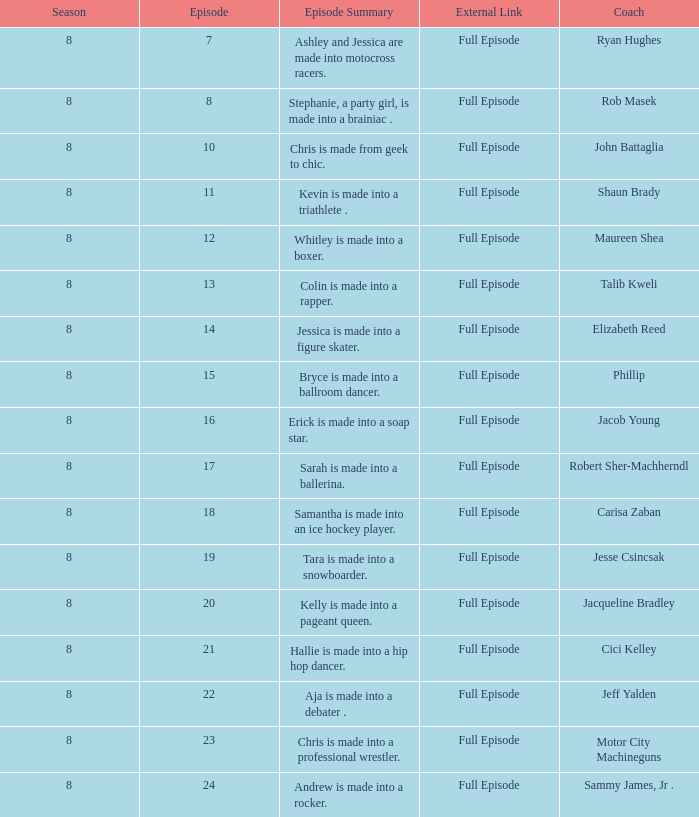Could you parse the entire table? {'header': ['Season', 'Episode', 'Episode Summary', 'External Link', 'Coach'], 'rows': [['8', '7', 'Ashley and Jessica are made into motocross racers.', 'Full Episode', 'Ryan Hughes'], ['8', '8', 'Stephanie, a party girl, is made into a brainiac .', 'Full Episode', 'Rob Masek'], ['8', '10', 'Chris is made from geek to chic.', 'Full Episode', 'John Battaglia'], ['8', '11', 'Kevin is made into a triathlete .', 'Full Episode', 'Shaun Brady'], ['8', '12', 'Whitley is made into a boxer.', 'Full Episode', 'Maureen Shea'], ['8', '13', 'Colin is made into a rapper.', 'Full Episode', 'Talib Kweli'], ['8', '14', 'Jessica is made into a figure skater.', 'Full Episode', 'Elizabeth Reed'], ['8', '15', 'Bryce is made into a ballroom dancer.', 'Full Episode', 'Phillip'], ['8', '16', 'Erick is made into a soap star.', 'Full Episode', 'Jacob Young'], ['8', '17', 'Sarah is made into a ballerina.', 'Full Episode', 'Robert Sher-Machherndl'], ['8', '18', 'Samantha is made into an ice hockey player.', 'Full Episode', 'Carisa Zaban'], ['8', '19', 'Tara is made into a snowboarder.', 'Full Episode', 'Jesse Csincsak'], ['8', '20', 'Kelly is made into a pageant queen.', 'Full Episode', 'Jacqueline Bradley'], ['8', '21', 'Hallie is made into a hip hop dancer.', 'Full Episode', 'Cici Kelley'], ['8', '22', 'Aja is made into a debater .', 'Full Episode', 'Jeff Yalden'], ['8', '23', 'Chris is made into a professional wrestler.', 'Full Episode', 'Motor City Machineguns'], ['8', '24', 'Andrew is made into a rocker.', 'Full Episode', 'Sammy James, Jr .']]} How many seasons feature Rob Masek? 1.0. 